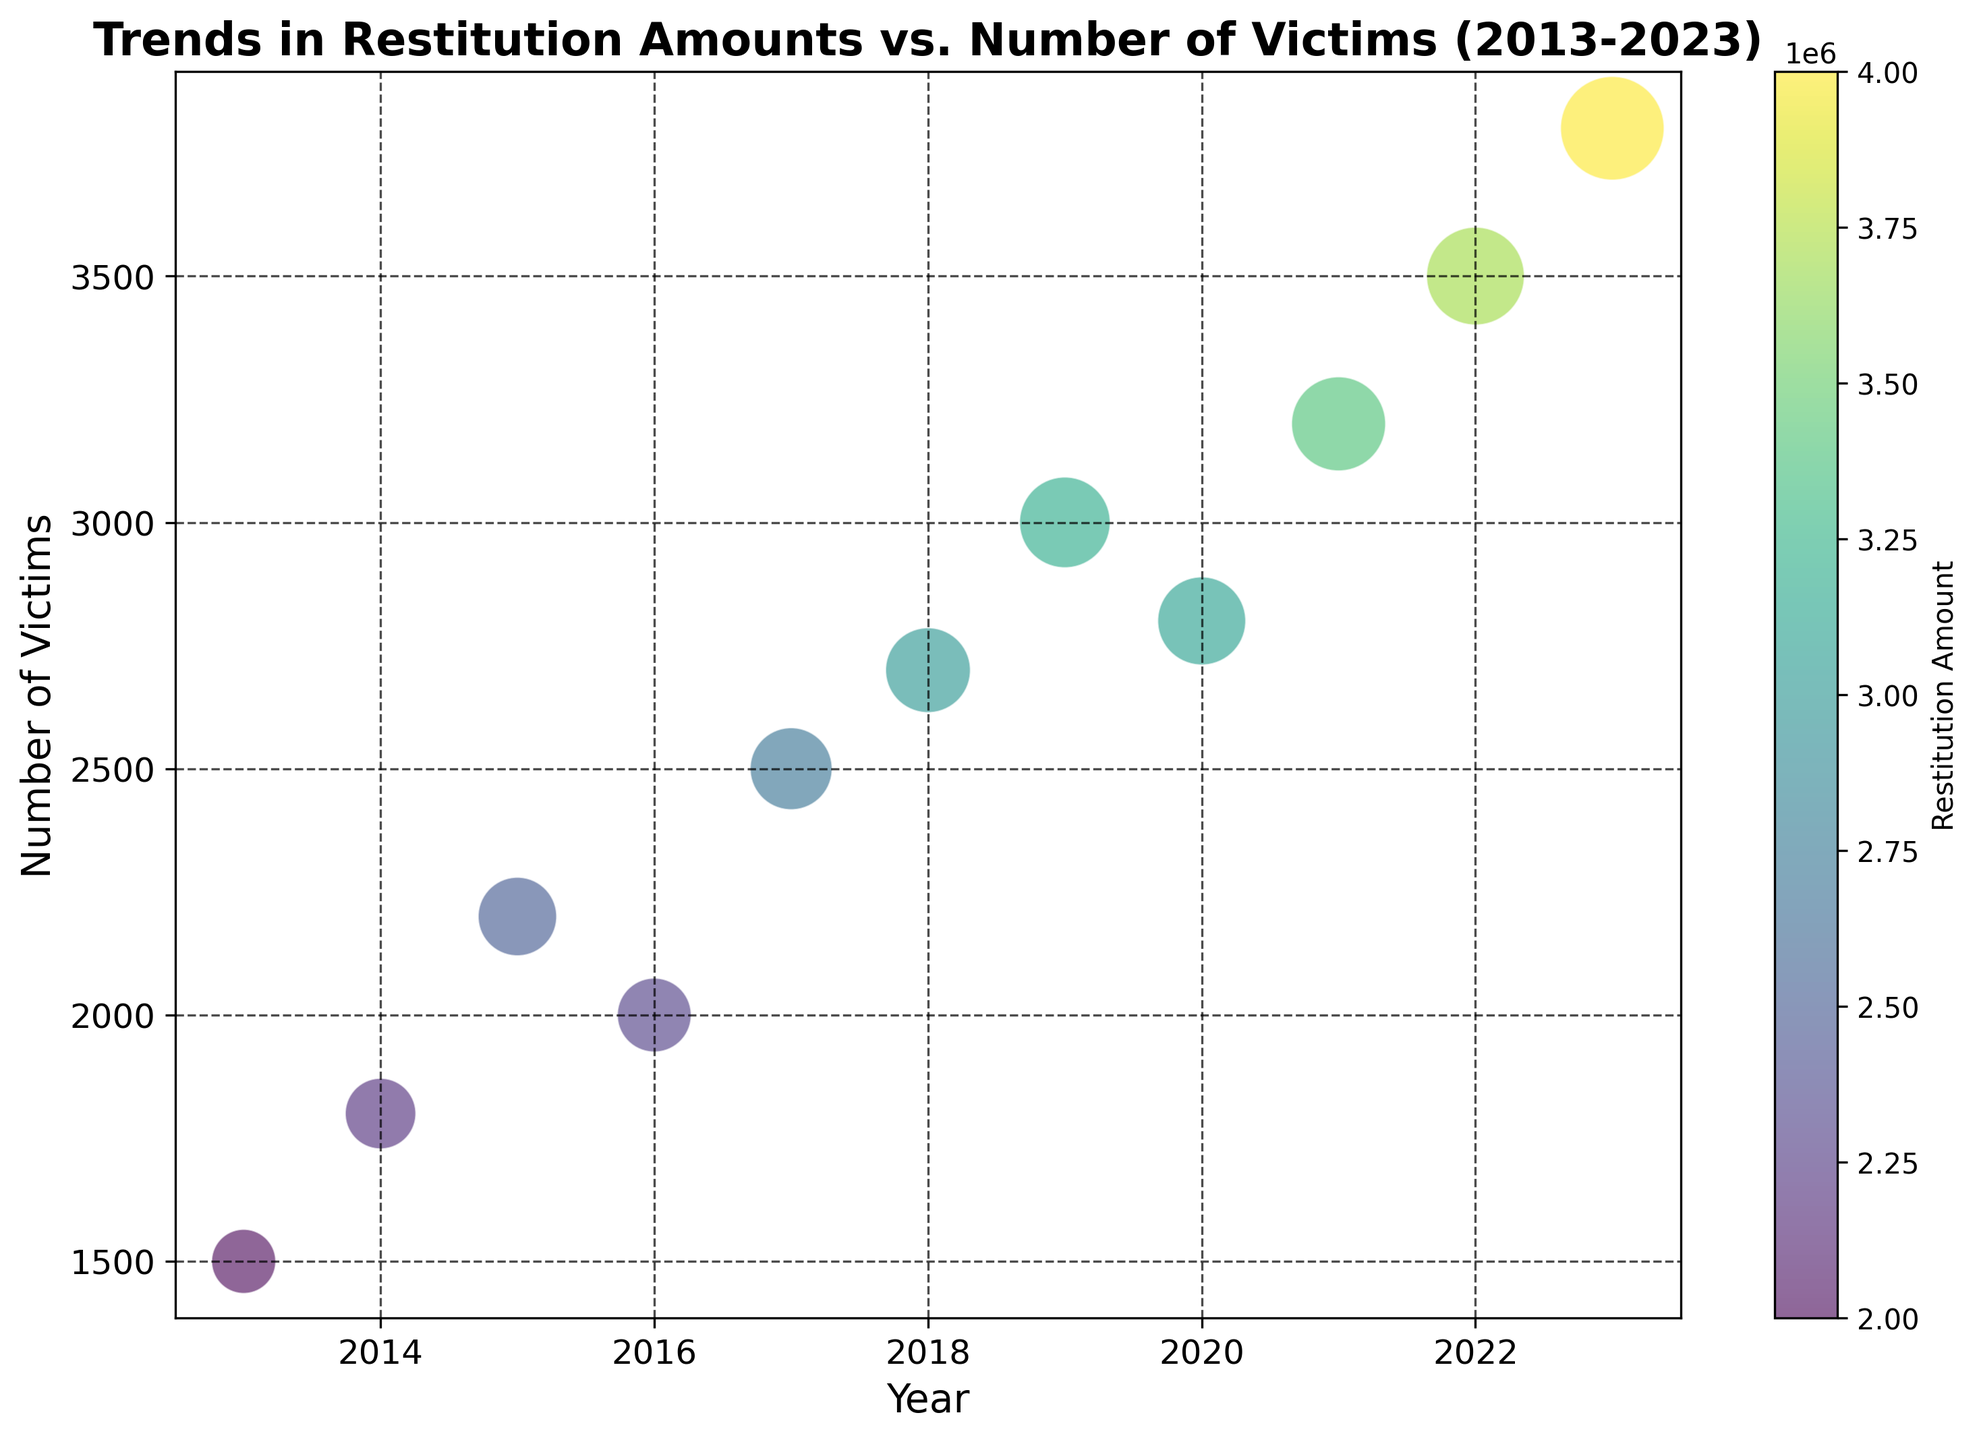Which year had the highest number of victims? The highest point on the y-axis represents the year with the most victims. By examining the figure, the year with the highest number of victims is 2023.
Answer: 2023 Which year had the lowest restitution amount? The color of the bubbles indicates the restitution amount, with darker colors representing higher amounts. The lightest colored bubble indicates the year with the lowest restitution, which is 2013.
Answer: 2013 What is the total number of victims from 2013 to 2023? Sum the y-values from each year: 1500 + 1800 + 2200 + 2000 + 2500 + 2700 + 3000 + 2800 + 3200 + 3500 + 3800 = 29000.
Answer: 29000 Which year had the largest bubble size, representing the highest impact factor? Bubbles with larger diameters indicate higher impact factors. The largest bubble can be visually identified as corresponding to 2023.
Answer: 2023 How does the restitution amount change from 2016 to 2017? Compare the color shades of the bubbles for 2016 and 2017. The bubble of 2017 is darker than that of 2016, indicating an increase in the restitution amount.
Answer: Increased Which year had more victims, 2015 or 2018? Compare the y-values of the bubbles for 2015 and 2018. The bubble for 2018 is higher on the y-axis than the one for 2015, indicating more victims in 2018.
Answer: 2018 Is the impact factor in 2020 higher or lower than in 2019? Observe the bubble sizes for 2019 and 2020. The bubble of 2019 is slightly larger than that of 2020, indicating a higher impact factor in 2019.
Answer: Lower Which year had an approximately average number of victims based on the entire period? With 11 data points, the median year will have the 6th highest number of victims. Visually identify the y-axis height—2018 with 2700 victims is close to the median.
Answer: 2018 How much did the restitution amount increase from 2019 to 2023? Calculate the difference between the restitution amounts for 2019 and 2023: 4000000 - 3200000 = 800000.
Answer: 800000 Which year had a similar number of victims but a higher restitution amount than 2020? Compare the y-values and colors of the bubbles. The year 2019 has a similar y-value but a darker color (indicating a higher restitution amount) than 2020.
Answer: 2019 